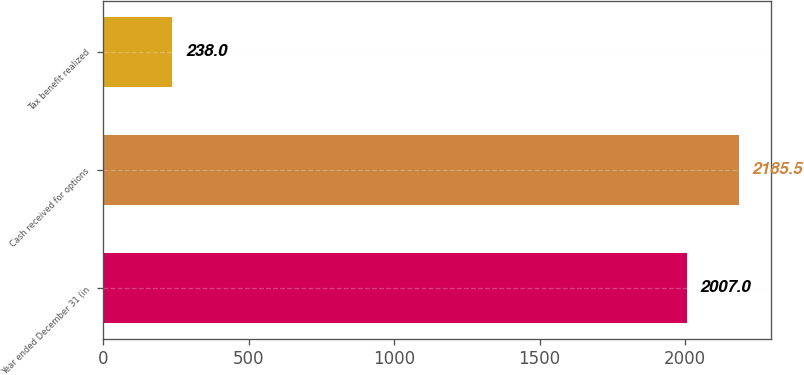Convert chart. <chart><loc_0><loc_0><loc_500><loc_500><bar_chart><fcel>Year ended December 31 (in<fcel>Cash received for options<fcel>Tax benefit realized<nl><fcel>2007<fcel>2185.5<fcel>238<nl></chart> 